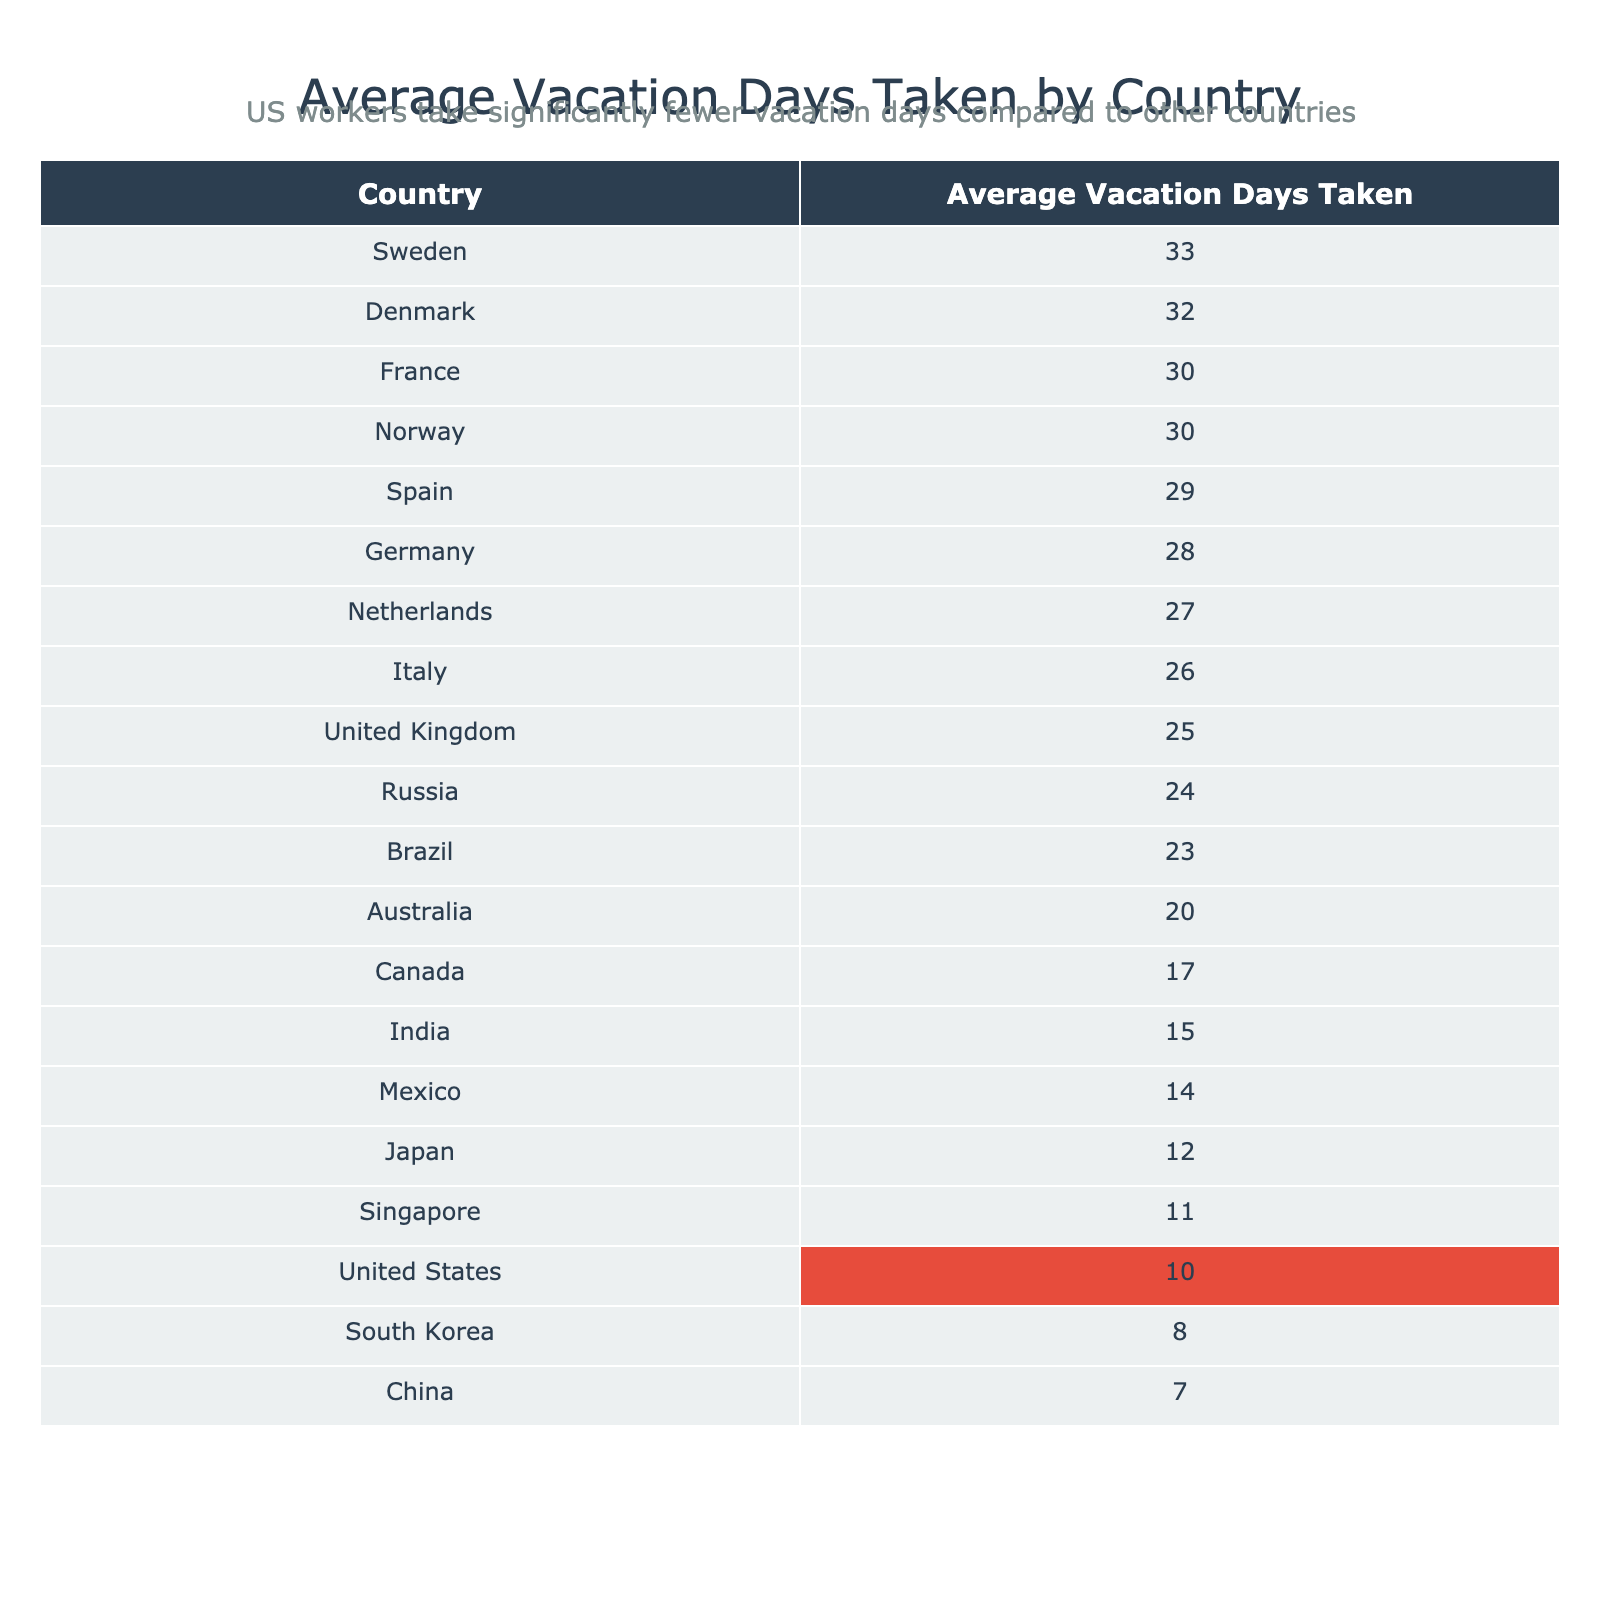What is the average number of vacation days taken by workers in the United States? The table shows that workers in the United States take an average of 10 vacation days.
Answer: 10 Which country has the highest average vacation days taken? Looking at the sorted table, Sweden has the highest average with 33 vacation days taken.
Answer: Sweden How many more vacation days does France take compared to Japan? France takes 30 vacation days while Japan takes 12, so the difference is 30 - 12 = 18 vacation days.
Answer: 18 Is it true that workers in the Netherlands take more vacation days than those in Canada? The table shows the Netherlands has 27 vacation days, while Canada has 17 vacation days, therefore the statement is true.
Answer: Yes What is the total number of vacation days taken by workers in Italy and Spain combined? Italy has 26 vacation days and Spain has 29 days, so the total is 26 + 29 = 55 vacation days.
Answer: 55 Which countries take fewer than 15 vacation days on average? According to the table, South Korea (8 days) and China (7 days) take fewer than 15 vacation days.
Answer: South Korea and China What is the average vacation days taken by the bottom three countries in terms of vacation days? The bottom three countries are South Korea (8), China (7), and the United States (10). The average is (8 + 7 + 10) / 3 = 25 / 3 = approximately 8.33 days.
Answer: Approximately 8.33 How many more vacation days does Denmark provide compared to the United States? Denmark has 32 vacation days and the United States has 10, so the difference is 32 - 10 = 22 vacation days.
Answer: 22 Which country has an average vacation day number closest to the median value of the entire dataset? First, find the median of the list [10, 12, 25, 30, 28, 26, 17, 20, 29, 33, 27, 32, 30, 23, 14, 8, 24, 7, 15, 11]. The median is 25. The country closest to 25 is Brazil with 23 days.
Answer: Brazil What is the range of vacation days taken by workers in these countries? The highest number of vacation days is 33 (Sweden) and the lowest is 7 (China), so the range is 33 - 7 = 26 days.
Answer: 26 Which two countries have an average vacation day number that is closest to each other? The countries with the closest average vacation days are Mexico (14) and Singapore (11), with a difference of only 3 days.
Answer: Mexico and Singapore 